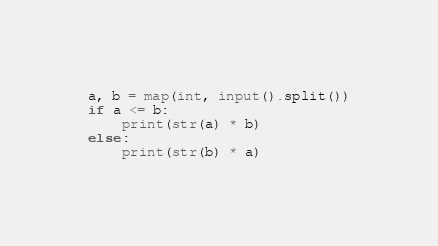<code> <loc_0><loc_0><loc_500><loc_500><_Python_>a, b = map(int, input().split())
if a <= b:
    print(str(a) * b)
else:
    print(str(b) * a)</code> 